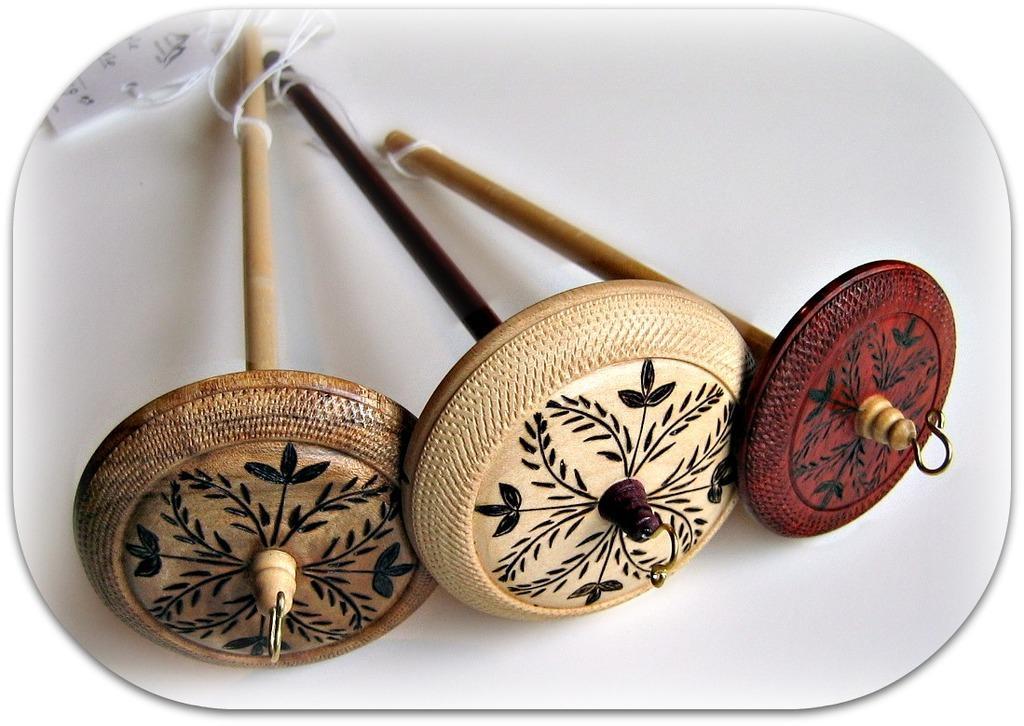Can you describe this image briefly? In this image we can see some wooden objects and also we can see the thread and a tag, the background is white. 